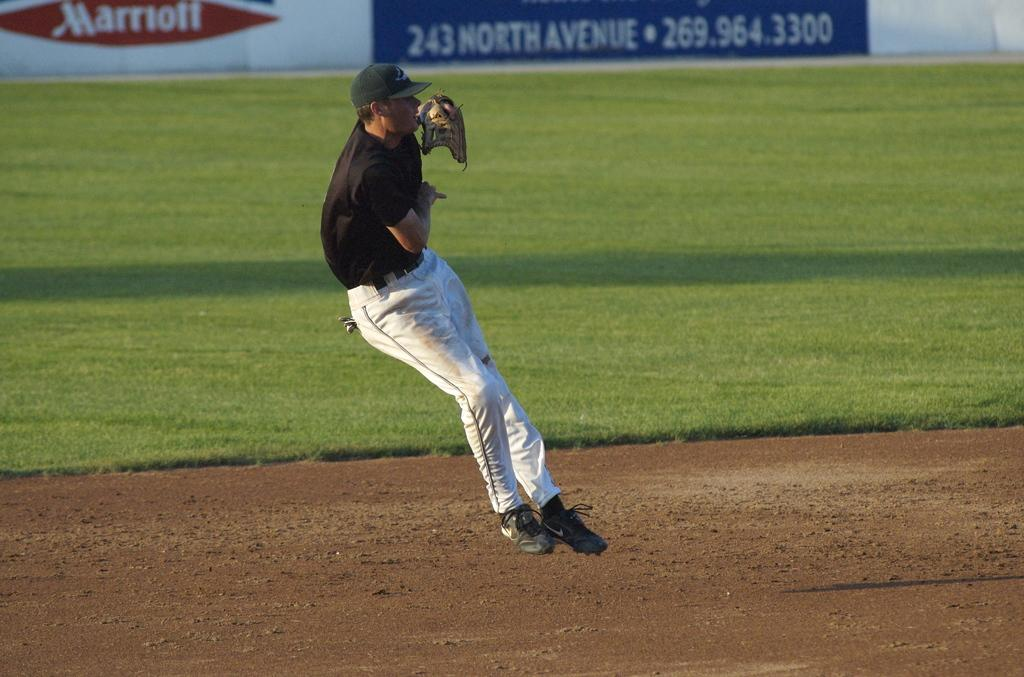<image>
Summarize the visual content of the image. A sports player mid jump and an advert for Marriott visible in the background. 